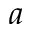<formula> <loc_0><loc_0><loc_500><loc_500>^ { a }</formula> 